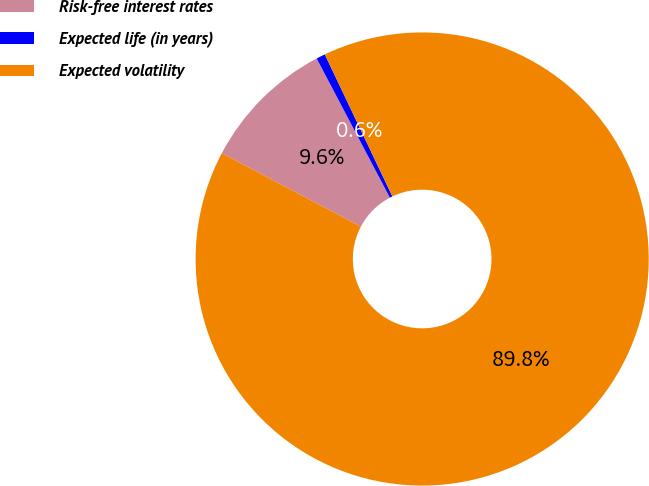Convert chart. <chart><loc_0><loc_0><loc_500><loc_500><pie_chart><fcel>Risk-free interest rates<fcel>Expected life (in years)<fcel>Expected volatility<nl><fcel>9.56%<fcel>0.64%<fcel>89.8%<nl></chart> 